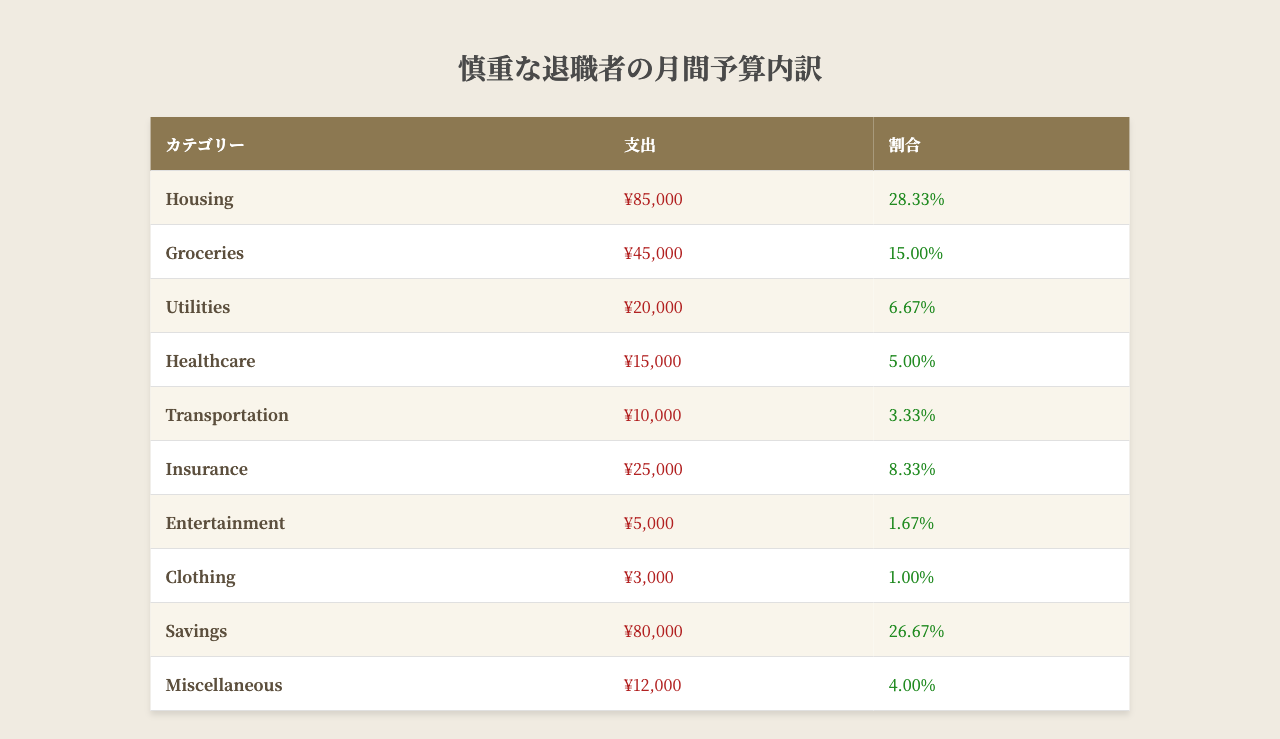What is the total monthly expense outlined in the budget? To find the total monthly expense, add all the individual expenses listed: ¥85,000 (Housing) + ¥45,000 (Groceries) + ¥20,000 (Utilities) + ¥15,000 (Healthcare) + ¥10,000 (Transportation) + ¥25,000 (Insurance) + ¥5,000 (Entertainment) + ¥3,000 (Clothing) + ¥80,000 (Savings) + ¥12,000 (Miscellaneous) = ¥295,000.
Answer: ¥295,000 What percentage of the budget is allocated for savings? The budget allocates ¥80,000 for savings, which is listed in the table as "26.67%." This can be directly retrieved from the savings category in the table.
Answer: 26.67% What is the highest single expense category? The highest single expense category is Housing, which has an expense of ¥85,000. This is the only category with this amount in the table, making it the largest.
Answer: Housing What is the total monthly expense for Utilities and Transportation combined? To find the combined total, add the expenses for Utilities (¥20,000) and Transportation (¥10,000): ¥20,000 + ¥10,000 = ¥30,000.
Answer: ¥30,000 Is the expense for Entertainment greater than the expense for Clothing? The expense for Entertainment is ¥5,000, and for Clothing, it is ¥3,000. Since ¥5,000 is greater than ¥3,000, the statement is true.
Answer: Yes How much of the budget is spent on healthcare compared to groceries? The healthcare expense is ¥15,000 and the groceries expense is ¥45,000. To compare, ¥15,000 is one-third of ¥45,000. This means healthcare spending is significantly less than groceries.
Answer: Healthcare is less than groceries What is the comparative percentage of Insurance expense relative to Transportation expense? The expense for Insurance is ¥25,000, and Transportation is ¥10,000. To find the comparative percentage: (¥25,000/¥10,000) * 100 = 250%. This means insurance expense is 2.5 times that of transportation in percentage terms.
Answer: 250% What is the combined percentage of Grocery and Housing expenses in the budget? The percentage for Groceries is 15.00% and for Housing is 28.33%. To find the combined percentage, add the two: 15.00% + 28.33% = 43.33%.
Answer: 43.33% If the miscellaneous expense is reduced by ¥2,000, what would be the new amount allocated for miscellaneous? The current miscellaneous expense is ¥12,000. If it is reduced by ¥2,000, the new amount would be ¥12,000 - ¥2,000 = ¥10,000.
Answer: ¥10,000 What fraction of the total budget is allocated to Clothing? The total budget is ¥295,000, and Clothing expense is ¥3,000. The fraction is ¥3,000/¥295,000. Simplifying gives approximately 1/98.
Answer: Approximately 1/98 How much more is spent on Housing than on Transportation? Housing expense is ¥85,000 and Transportation expense is ¥10,000. To find the difference: ¥85,000 - ¥10,000 = ¥75,000.
Answer: ¥75,000 